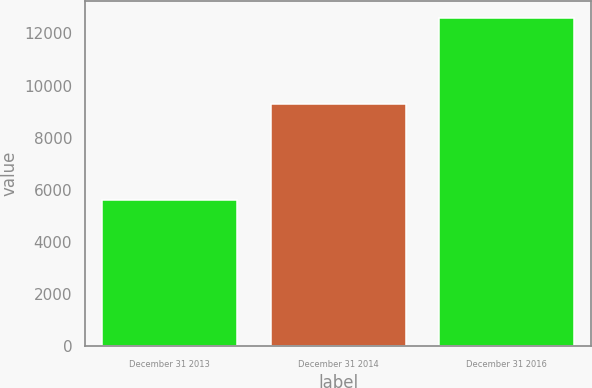Convert chart to OTSL. <chart><loc_0><loc_0><loc_500><loc_500><bar_chart><fcel>December 31 2013<fcel>December 31 2014<fcel>December 31 2016<nl><fcel>5622<fcel>9309<fcel>12608<nl></chart> 